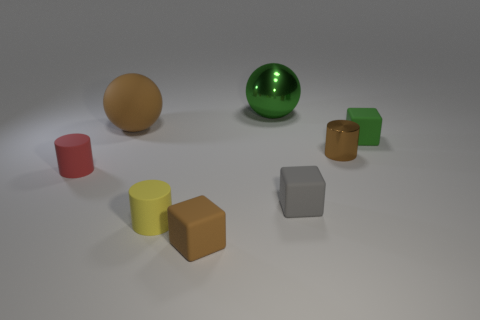Subtract 1 cubes. How many cubes are left? 2 Add 2 small rubber things. How many objects exist? 10 Subtract all cylinders. How many objects are left? 5 Subtract 0 gray spheres. How many objects are left? 8 Subtract all brown spheres. Subtract all big rubber things. How many objects are left? 6 Add 7 green matte cubes. How many green matte cubes are left? 8 Add 5 big cylinders. How many big cylinders exist? 5 